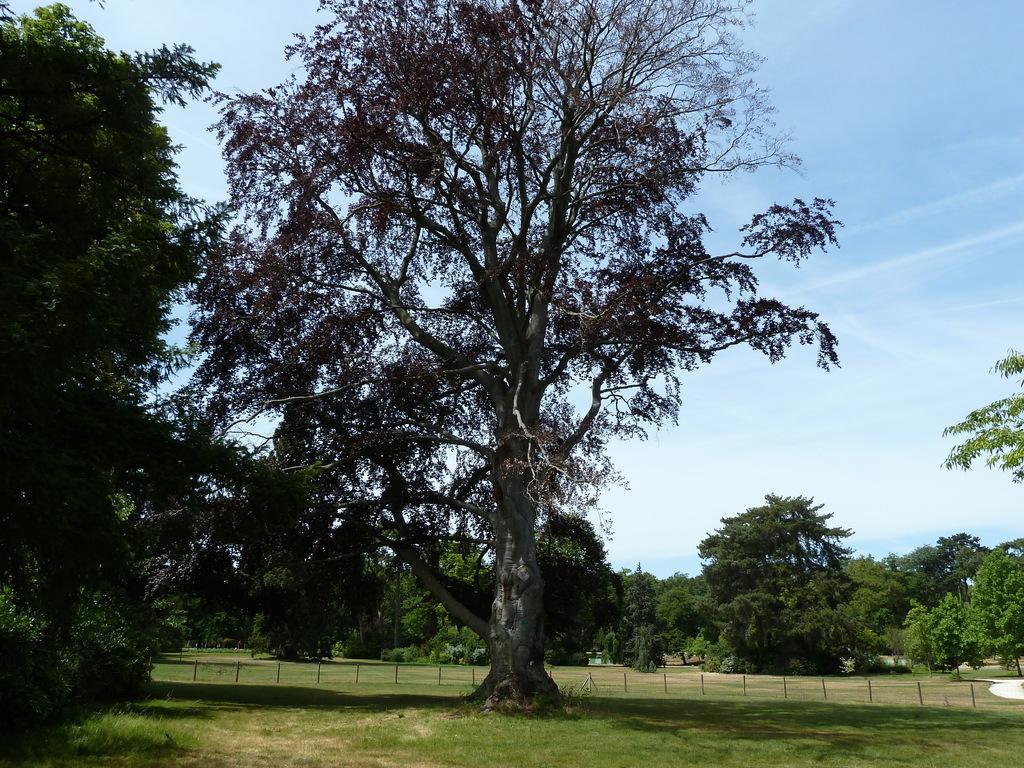Please provide a concise description of this image. In this picture I can see grass, there are trees, there are wooden poles, and in the background there is the sky. 